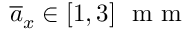<formula> <loc_0><loc_0><loc_500><loc_500>\overline { a } _ { x } \in \left [ 1 , 3 \right ] \, m m</formula> 